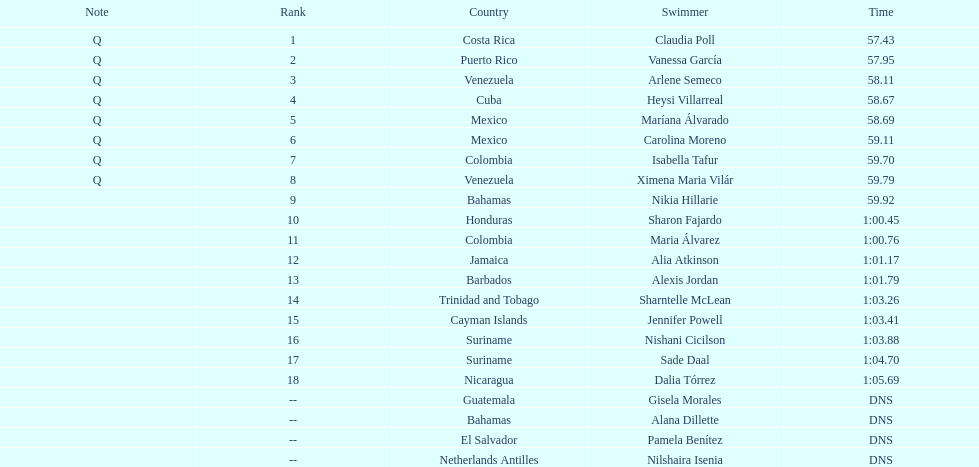Write the full table. {'header': ['Note', 'Rank', 'Country', 'Swimmer', 'Time'], 'rows': [['Q', '1', 'Costa Rica', 'Claudia Poll', '57.43'], ['Q', '2', 'Puerto Rico', 'Vanessa García', '57.95'], ['Q', '3', 'Venezuela', 'Arlene Semeco', '58.11'], ['Q', '4', 'Cuba', 'Heysi Villarreal', '58.67'], ['Q', '5', 'Mexico', 'Maríana Álvarado', '58.69'], ['Q', '6', 'Mexico', 'Carolina Moreno', '59.11'], ['Q', '7', 'Colombia', 'Isabella Tafur', '59.70'], ['Q', '8', 'Venezuela', 'Ximena Maria Vilár', '59.79'], ['', '9', 'Bahamas', 'Nikia Hillarie', '59.92'], ['', '10', 'Honduras', 'Sharon Fajardo', '1:00.45'], ['', '11', 'Colombia', 'Maria Álvarez', '1:00.76'], ['', '12', 'Jamaica', 'Alia Atkinson', '1:01.17'], ['', '13', 'Barbados', 'Alexis Jordan', '1:01.79'], ['', '14', 'Trinidad and Tobago', 'Sharntelle McLean', '1:03.26'], ['', '15', 'Cayman Islands', 'Jennifer Powell', '1:03.41'], ['', '16', 'Suriname', 'Nishani Cicilson', '1:03.88'], ['', '17', 'Suriname', 'Sade Daal', '1:04.70'], ['', '18', 'Nicaragua', 'Dalia Tórrez', '1:05.69'], ['', '--', 'Guatemala', 'Gisela Morales', 'DNS'], ['', '--', 'Bahamas', 'Alana Dillette', 'DNS'], ['', '--', 'El Salvador', 'Pamela Benítez', 'DNS'], ['', '--', 'Netherlands Antilles', 'Nilshaira Isenia', 'DNS']]} Who was the only cuban to finish in the top eight? Heysi Villarreal. 